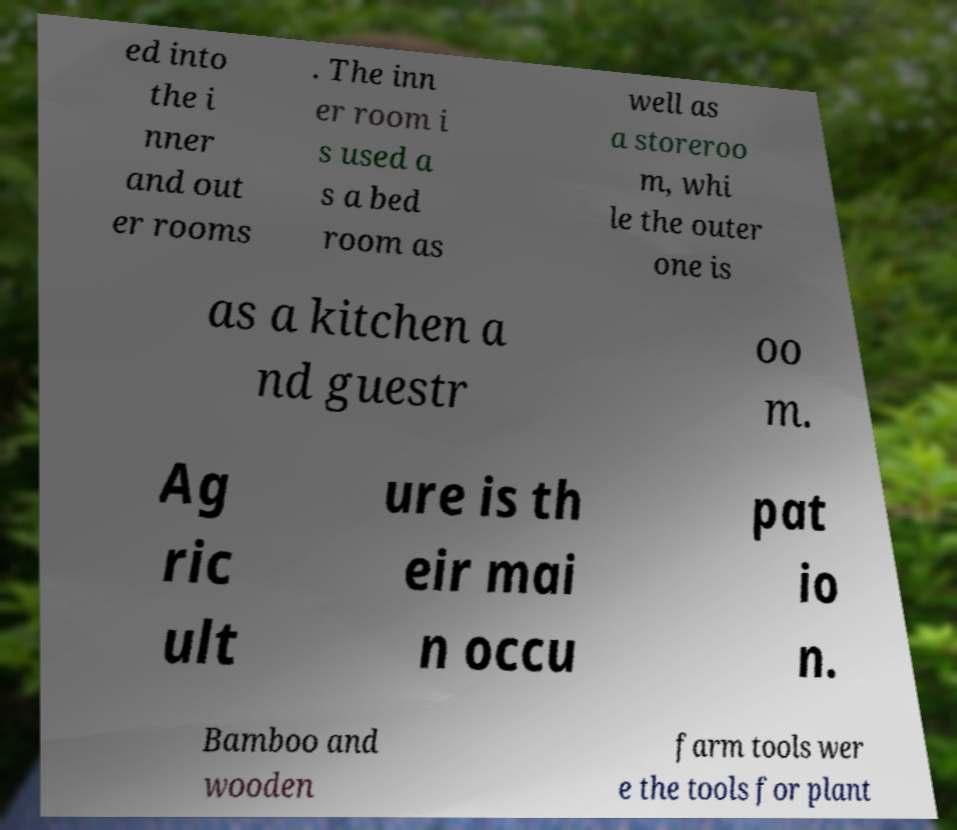What messages or text are displayed in this image? I need them in a readable, typed format. ed into the i nner and out er rooms . The inn er room i s used a s a bed room as well as a storeroo m, whi le the outer one is as a kitchen a nd guestr oo m. Ag ric ult ure is th eir mai n occu pat io n. Bamboo and wooden farm tools wer e the tools for plant 